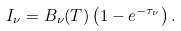Convert formula to latex. <formula><loc_0><loc_0><loc_500><loc_500>I _ { \nu } = B _ { \nu } ( T ) \left ( 1 - e ^ { - \tau _ { \nu } } \right ) .</formula> 